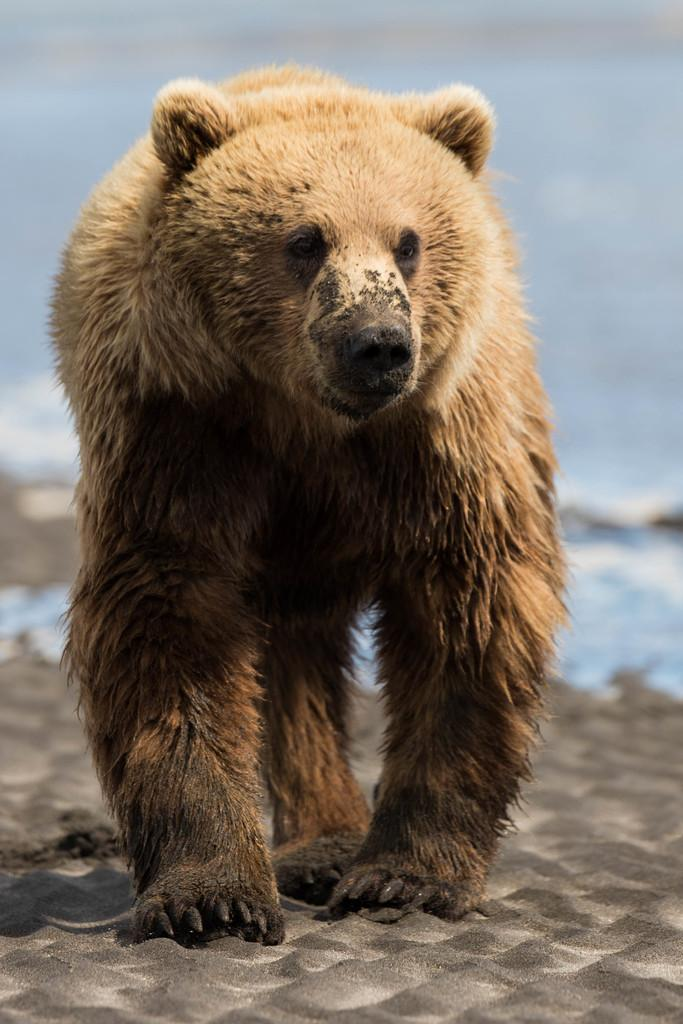What animal is in the image? There is a bear in the image. Where is the bear located? The bear is on the sand. Can you describe the background of the image? The background of the image is blurry. What type of jeans is the bear wearing in the image? There are no jeans present in the image, as bears do not wear clothing. 